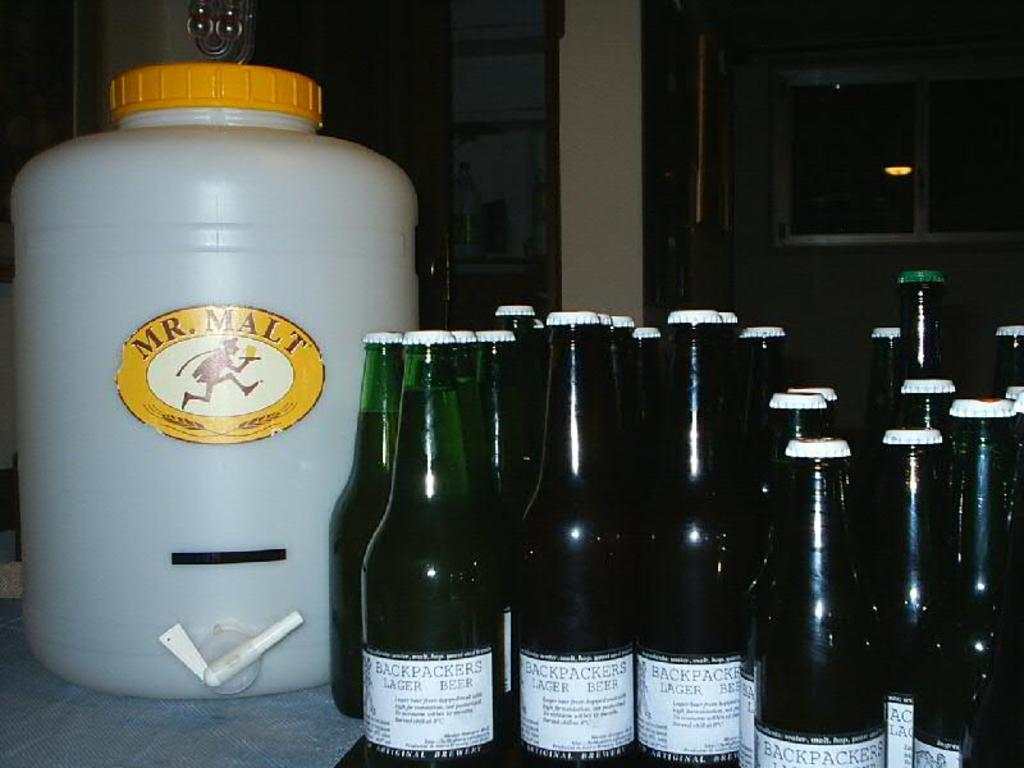<image>
Present a compact description of the photo's key features. the word malt that is on a bottle 